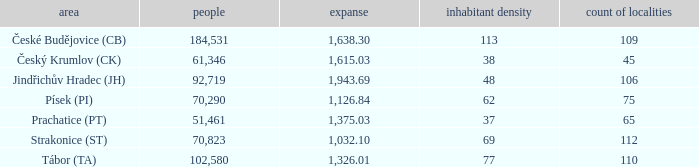Would you mind parsing the complete table? {'header': ['area', 'people', 'expanse', 'inhabitant density', 'count of localities'], 'rows': [['České Budějovice (CB)', '184,531', '1,638.30', '113', '109'], ['Český Krumlov (CK)', '61,346', '1,615.03', '38', '45'], ['Jindřichův Hradec (JH)', '92,719', '1,943.69', '48', '106'], ['Písek (PI)', '70,290', '1,126.84', '62', '75'], ['Prachatice (PT)', '51,461', '1,375.03', '37', '65'], ['Strakonice (ST)', '70,823', '1,032.10', '69', '112'], ['Tábor (TA)', '102,580', '1,326.01', '77', '110']]} What is the lowest population density of Strakonice (st) with more than 112 settlements? None. 